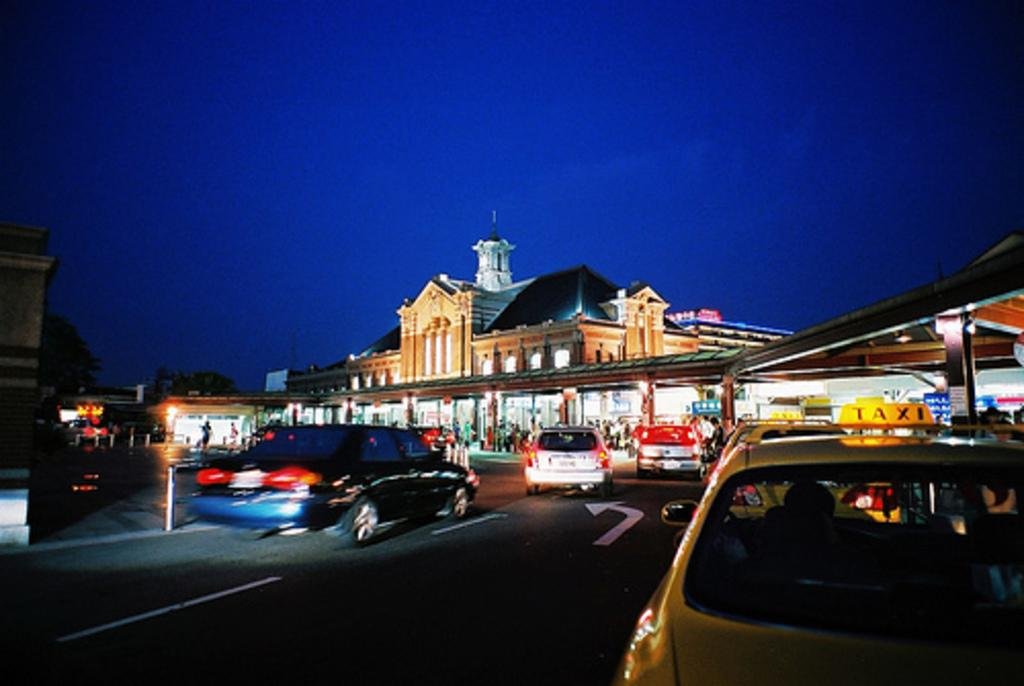Provide a one-sentence caption for the provided image. A yellow car that has a TAXI sign on the top of it drives on a street at night with several other cars. 